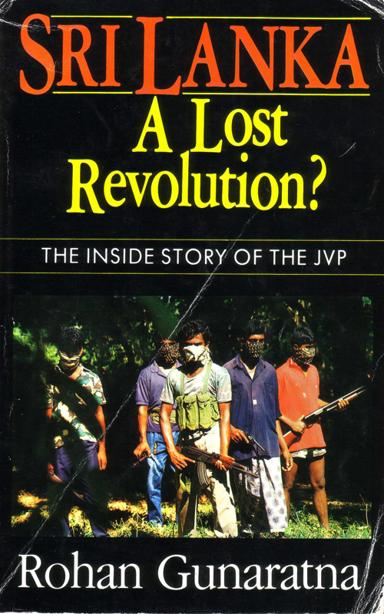What is the title of the book mentioned in the image? The title of the book depicted in the image is "Sri Lanka: A Lost Revolution? The Inside Story of the JVP". This book, authored by Rohan Gunaratna, delves into the complex history of the Janatha Vimukthi Peramuna (JVP) movement in Sri Lanka, providing an in-depth look into its political and social implications. 